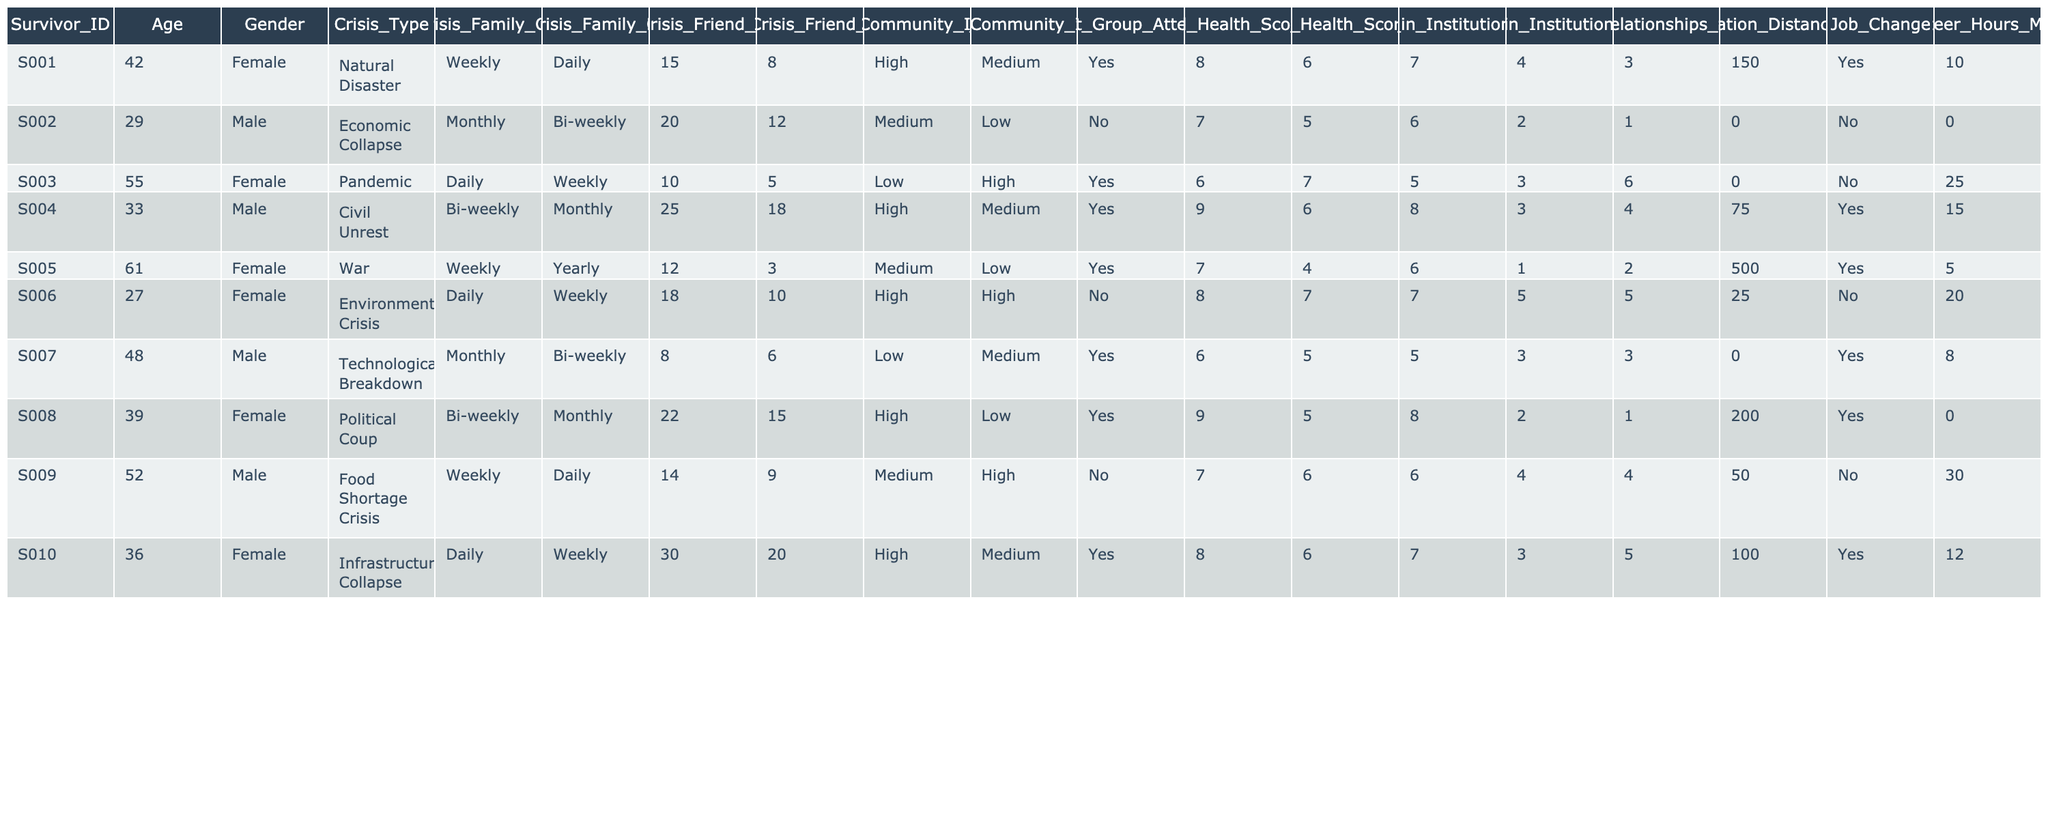What was the pre-crisis family contact frequency for Survivor S005? The table indicates that Survivor S005 had a pre-crisis family contact frequency of "Weekly".
Answer: Weekly How many survivors had a mental health score decrease after their respective crises? To determine this, we compare the Mental Health Score Pre and Post for each survivor. Survivors S001, S002, S004, S005, S007, S009, and S010 all experienced a decrease in their score. Thus, there are 6 survivors who had a decrease.
Answer: 6 What was the change in the friend count for Survivor S003? The pre-crisis friend count for Survivor S003 was 10, and the post-crisis count is 5. The difference is 10 - 5 = 5. Therefore, Survivor S003 lost 5 friends after the crisis.
Answer: 5 Did any survivors form new relationships during or after the crisis? Looking at the 'New Relationships Formed' column, Survivors S001, S004, S005, S006, S008, and S010 all reported forming new relationships. Therefore, at least some survivors formed new relationships.
Answer: Yes What is the average mental health score before the crisis for the survivors? We calculate the average by adding all the pre-crisis mental health scores: (8 + 7 + 6 + 9 + 7 + 8 + 6 + 9 + 7 + 8) = 79, and then divide by the number of survivors, which is 10. So, 79/10 = 7.9. Therefore, the average pre-crisis mental health score is 7.9.
Answer: 7.9 How many survivors increased their community involvement after the crisis? By checking the 'Pre_Crisis_Community_Involvement' and 'Post_Crisis_Community_Involvement' columns, we see that Survivors S003, S004, S006, and S009 experienced an increase in their community involvement (from Low or Medium to High). This yields a count of 4 survivors who increased their community involvement.
Answer: 4 Which survivor had the highest relocation distance, and what was it? The ‘Relocation Distance km' shows that Survivor S005 had the highest relocation distance of 500 km.
Answer: 500 km What is the difference in job change status between survivors S002 and S010? Survivor S002 did not make a job change (No), while Survivor S010 did make a job change (Yes). Hence, the difference is that one changed jobs, while the other did not.
Answer: S010 changed jobs; S002 did not Which crisis caused the largest average decrease in mental health scores? We calculate the average decrease in mental health scores for each crisis type. The total decrease values calculated per crisis type and their counts lead us to find that the Pandemic crisis caused the highest average decrease, averaging around 1. The complete breakdown shows that out of all 10 survivors, the Pandemic crisis had the highest count of negative change in mental health scores.
Answer: Pandemic How many survivors had a decrease in trust in institutions after the crisis? Assessing the 'Trust_in_Institutions_Pre' and 'Trust_in_Institutions_Post', we note that survivors S001, S002, S005, S008, and S009 reported a decrease in trust in institutions. Thus, 5 survivors had a decrease in trust.
Answer: 5 What percentage of survivors attended a support group before their crisis? Since 3 out of the 10 survivors attended support groups before the crisis, the percentage is (3/10) * 100 = 30%. Thus, 30% of the survivors attended a support group prior to their crisis.
Answer: 30% 